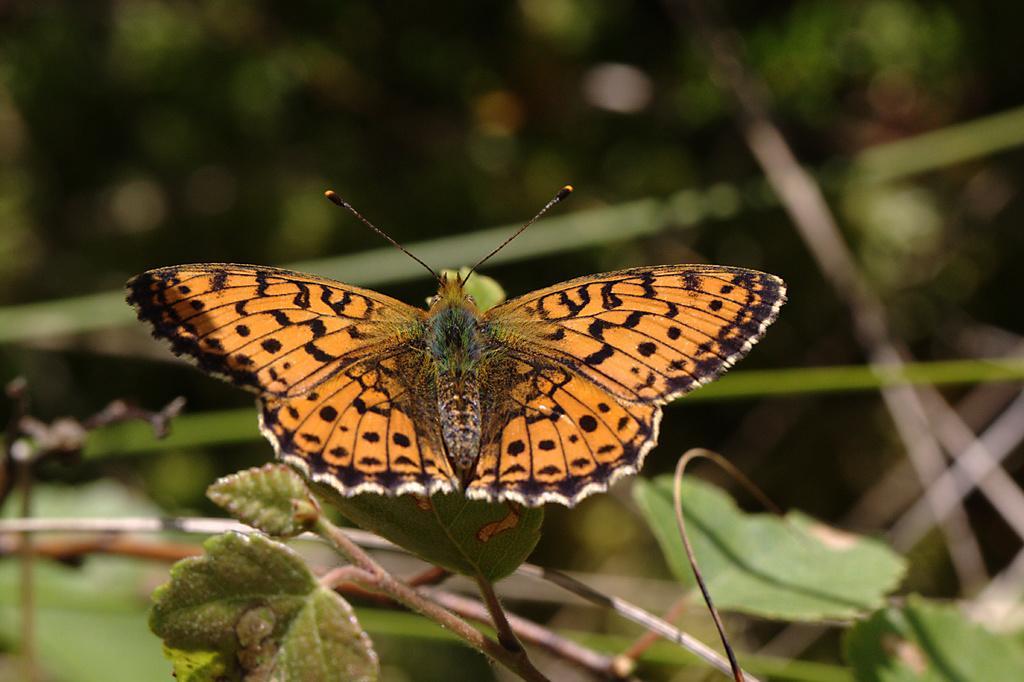Can you describe this image briefly? In the picture I can see an orange color butterfly on the plant leaves and the background of the image is blurred. 